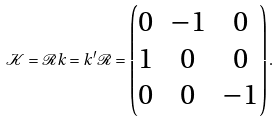Convert formula to latex. <formula><loc_0><loc_0><loc_500><loc_500>\mathcal { K } = \mathcal { R } k = k ^ { \prime } \mathcal { R } = \begin{pmatrix} 0 & - 1 & 0 \\ 1 & 0 & 0 \\ 0 & 0 & - 1 \end{pmatrix} .</formula> 